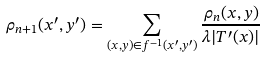<formula> <loc_0><loc_0><loc_500><loc_500>\rho _ { n + 1 } ( x ^ { \prime } , y ^ { \prime } ) = \sum _ { ( x , y ) \in f ^ { - 1 } ( x ^ { \prime } , y ^ { \prime } ) } \frac { \rho _ { n } ( x , y ) } { \lambda | T ^ { \prime } ( x ) | }</formula> 